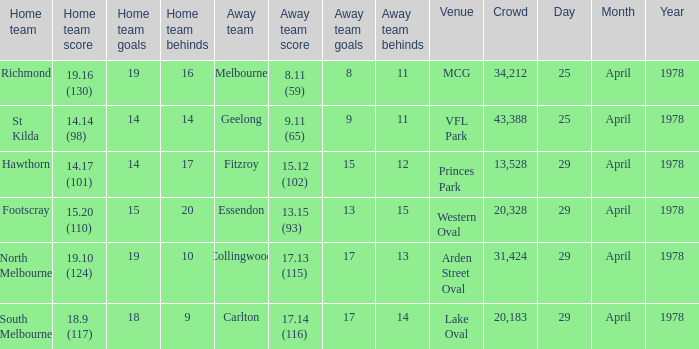In what venue was the hosted away team Essendon? Western Oval. 